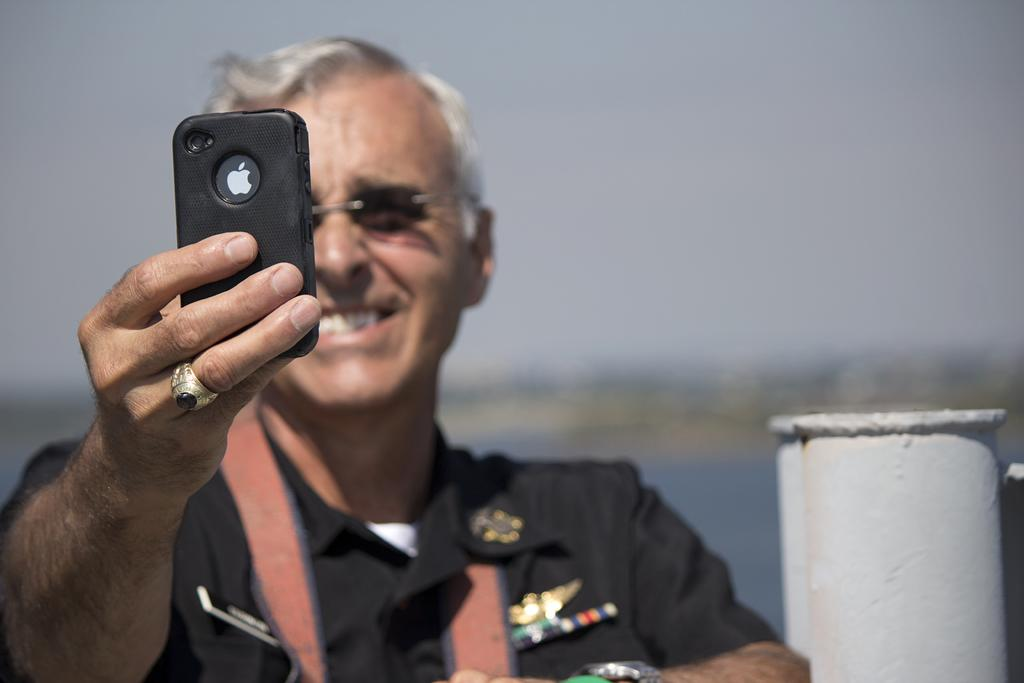What is the main subject of the image? There is a person in the image. What is the person holding in his hand? The person is holding a mobile in his hand. What is the person's facial expression? The person is smiling. What can be seen on the right side of the image? There is a pole on the right side of the image. What is visible behind the person? There is a lake behind the person. What is the condition of the sky in the image? The sky is clear in the image. What type of flag is visible on the floor in the image? There is no flag present in the image, and the floor is not visible. What kind of wilderness can be seen in the background of the image? There is no wilderness visible in the image; it features a person, a pole, a lake, and a clear sky. 